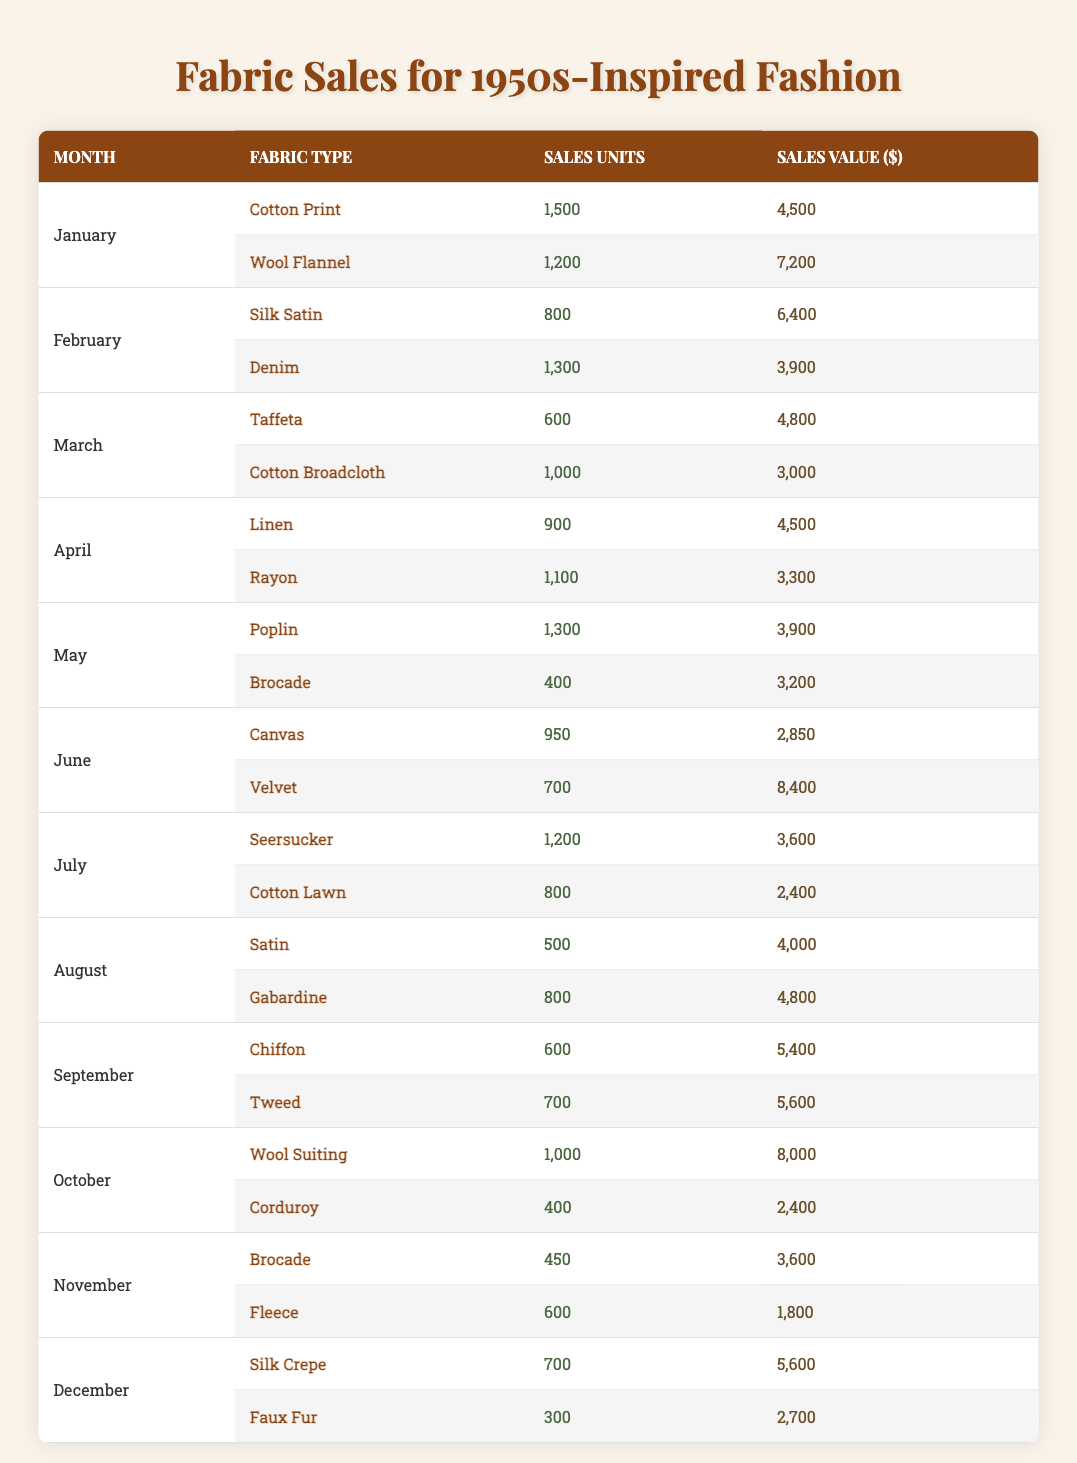What are the total sales units for "Cotton Print" in January? In January, "Cotton Print" has a sales unit of 1,500 according to the table.
Answer: 1,500 Which fabric type had the highest sales value in June? In June, "Velvet" had a sales value of $8,400, which is higher than "Canvas" at $2,850.
Answer: Velvet How many units of "Wool Flannel" were sold in January compared to "Wool Suiting" in October? In January, "Wool Flannel" sold 1,200 units, while in October, "Wool Suiting" sold 1,000 units. "Wool Flannel" had 200 more units than "Wool Suiting."
Answer: 200 more What is the average sales value across all fabric types sold in April? In April, "Linen" had a sales value of $4,500 and "Rayon" had $3,300. The total sales value is $4,500 + $3,300 = $7,800. The average is $7,800 / 2 = $3,900.
Answer: 3,900 Is it true that "Gabardine" had higher sales units than "Seersucker" in July? In July, "Seersucker" had 1,200 sales units, which is greater than "Gabardine" at 800 units. Therefore, the statement is false.
Answer: No What is the total sales value of "Brocade" sold in May and November combined? In May, "Brocade" had a sales value of $3,200 and in November it had $3,600. The total sales value is $3,200 + $3,600 = $6,800.
Answer: 6,800 Which month saw a higher sales unit total—September or December? In September, "Chiffon" sold 600 and "Tweed" sold 700, totaling 1,300 units. In December, "Silk Crepe" sold 700 and "Faux Fur" sold 300, totaling 1,000 units. September had the higher total.
Answer: September What percentage of total sales value in July was accounted for by "Cotton Lawn"? In July, "Seersucker" had a sales value of $3,600 and "Cotton Lawn" had $2,400. The total sales value for July is $3,600 + $2,400 = $6,000. The percentage for "Cotton Lawn" is ($2,400 / $6,000) * 100 = 40%.
Answer: 40% If you compare the sales values of "Silk Satin" and "Denim" in February, which was higher and by how much? "Silk Satin" sold for $6,400 and "Denim" for $3,900. The difference is $6,400 - $3,900 = $2,500. Thus, "Silk Satin" was higher by $2,500.
Answer: 2,500 Which fabric had the lowest sales units in August? In August, "Satin" had 500 sales units, and "Gabardine" had 800 sales units. Therefore, "Satin" had the lowest sales units in that month.
Answer: Satin How many total fabric types were sold in the first half of the year (January to June)? From January to June, the fabric types sold were: Cotton Print, Wool Flannel, Silk Satin, Denim, Taffeta, Cotton Broadcloth, Linen, Rayon, Poplin, Brocade, Canvas, and Velvet. This totals to 12 fabric types.
Answer: 12 